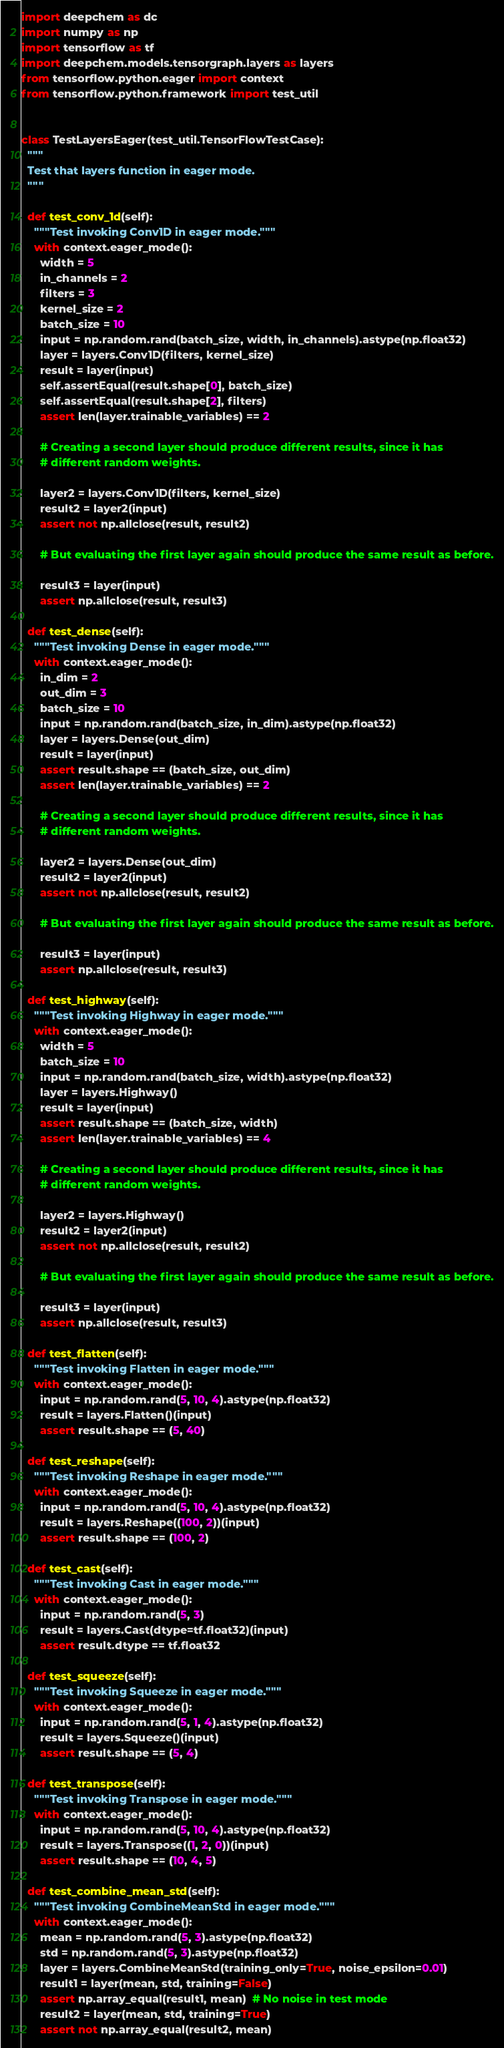Convert code to text. <code><loc_0><loc_0><loc_500><loc_500><_Python_>import deepchem as dc
import numpy as np
import tensorflow as tf
import deepchem.models.tensorgraph.layers as layers
from tensorflow.python.eager import context
from tensorflow.python.framework import test_util


class TestLayersEager(test_util.TensorFlowTestCase):
  """
  Test that layers function in eager mode.
  """

  def test_conv_1d(self):
    """Test invoking Conv1D in eager mode."""
    with context.eager_mode():
      width = 5
      in_channels = 2
      filters = 3
      kernel_size = 2
      batch_size = 10
      input = np.random.rand(batch_size, width, in_channels).astype(np.float32)
      layer = layers.Conv1D(filters, kernel_size)
      result = layer(input)
      self.assertEqual(result.shape[0], batch_size)
      self.assertEqual(result.shape[2], filters)
      assert len(layer.trainable_variables) == 2

      # Creating a second layer should produce different results, since it has
      # different random weights.

      layer2 = layers.Conv1D(filters, kernel_size)
      result2 = layer2(input)
      assert not np.allclose(result, result2)

      # But evaluating the first layer again should produce the same result as before.

      result3 = layer(input)
      assert np.allclose(result, result3)

  def test_dense(self):
    """Test invoking Dense in eager mode."""
    with context.eager_mode():
      in_dim = 2
      out_dim = 3
      batch_size = 10
      input = np.random.rand(batch_size, in_dim).astype(np.float32)
      layer = layers.Dense(out_dim)
      result = layer(input)
      assert result.shape == (batch_size, out_dim)
      assert len(layer.trainable_variables) == 2

      # Creating a second layer should produce different results, since it has
      # different random weights.

      layer2 = layers.Dense(out_dim)
      result2 = layer2(input)
      assert not np.allclose(result, result2)

      # But evaluating the first layer again should produce the same result as before.

      result3 = layer(input)
      assert np.allclose(result, result3)

  def test_highway(self):
    """Test invoking Highway in eager mode."""
    with context.eager_mode():
      width = 5
      batch_size = 10
      input = np.random.rand(batch_size, width).astype(np.float32)
      layer = layers.Highway()
      result = layer(input)
      assert result.shape == (batch_size, width)
      assert len(layer.trainable_variables) == 4

      # Creating a second layer should produce different results, since it has
      # different random weights.

      layer2 = layers.Highway()
      result2 = layer2(input)
      assert not np.allclose(result, result2)

      # But evaluating the first layer again should produce the same result as before.

      result3 = layer(input)
      assert np.allclose(result, result3)

  def test_flatten(self):
    """Test invoking Flatten in eager mode."""
    with context.eager_mode():
      input = np.random.rand(5, 10, 4).astype(np.float32)
      result = layers.Flatten()(input)
      assert result.shape == (5, 40)

  def test_reshape(self):
    """Test invoking Reshape in eager mode."""
    with context.eager_mode():
      input = np.random.rand(5, 10, 4).astype(np.float32)
      result = layers.Reshape((100, 2))(input)
      assert result.shape == (100, 2)

  def test_cast(self):
    """Test invoking Cast in eager mode."""
    with context.eager_mode():
      input = np.random.rand(5, 3)
      result = layers.Cast(dtype=tf.float32)(input)
      assert result.dtype == tf.float32

  def test_squeeze(self):
    """Test invoking Squeeze in eager mode."""
    with context.eager_mode():
      input = np.random.rand(5, 1, 4).astype(np.float32)
      result = layers.Squeeze()(input)
      assert result.shape == (5, 4)

  def test_transpose(self):
    """Test invoking Transpose in eager mode."""
    with context.eager_mode():
      input = np.random.rand(5, 10, 4).astype(np.float32)
      result = layers.Transpose((1, 2, 0))(input)
      assert result.shape == (10, 4, 5)

  def test_combine_mean_std(self):
    """Test invoking CombineMeanStd in eager mode."""
    with context.eager_mode():
      mean = np.random.rand(5, 3).astype(np.float32)
      std = np.random.rand(5, 3).astype(np.float32)
      layer = layers.CombineMeanStd(training_only=True, noise_epsilon=0.01)
      result1 = layer(mean, std, training=False)
      assert np.array_equal(result1, mean)  # No noise in test mode
      result2 = layer(mean, std, training=True)
      assert not np.array_equal(result2, mean)</code> 